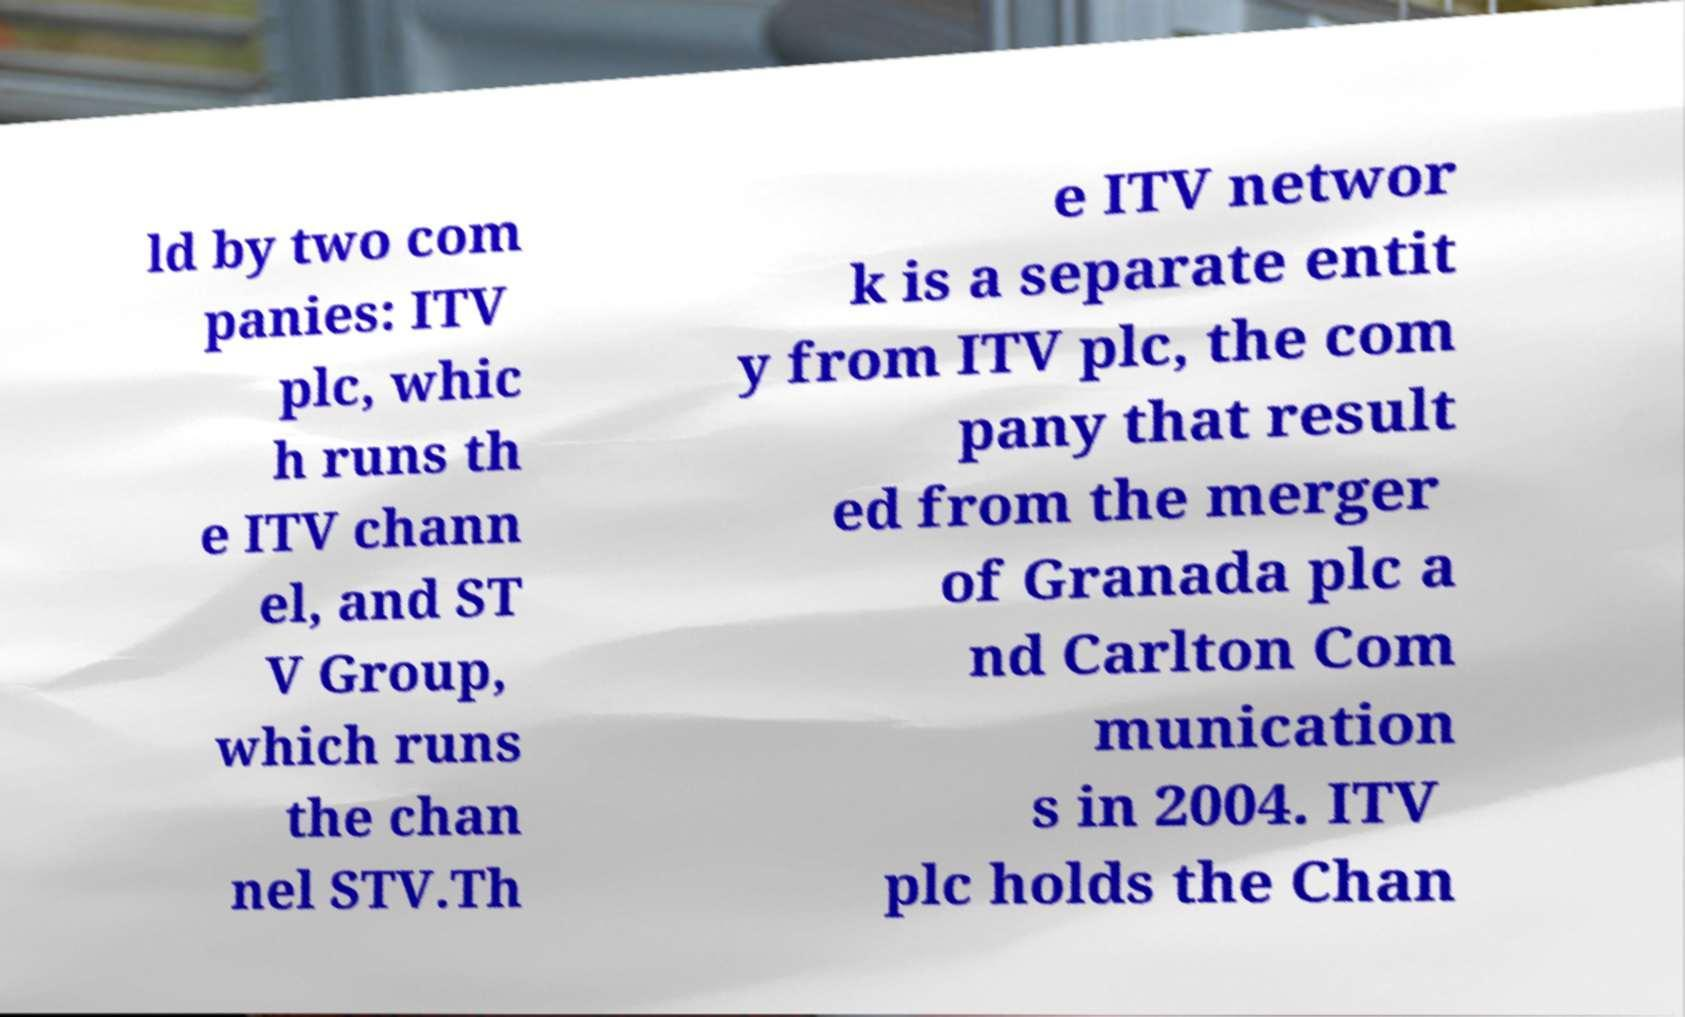Could you extract and type out the text from this image? ld by two com panies: ITV plc, whic h runs th e ITV chann el, and ST V Group, which runs the chan nel STV.Th e ITV networ k is a separate entit y from ITV plc, the com pany that result ed from the merger of Granada plc a nd Carlton Com munication s in 2004. ITV plc holds the Chan 